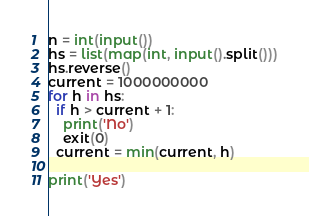Convert code to text. <code><loc_0><loc_0><loc_500><loc_500><_Python_>n = int(input())
hs = list(map(int, input().split()))
hs.reverse()
current = 1000000000
for h in hs:
  if h > current + 1:
    print('No')
    exit(0)
  current = min(current, h)

print('Yes')</code> 